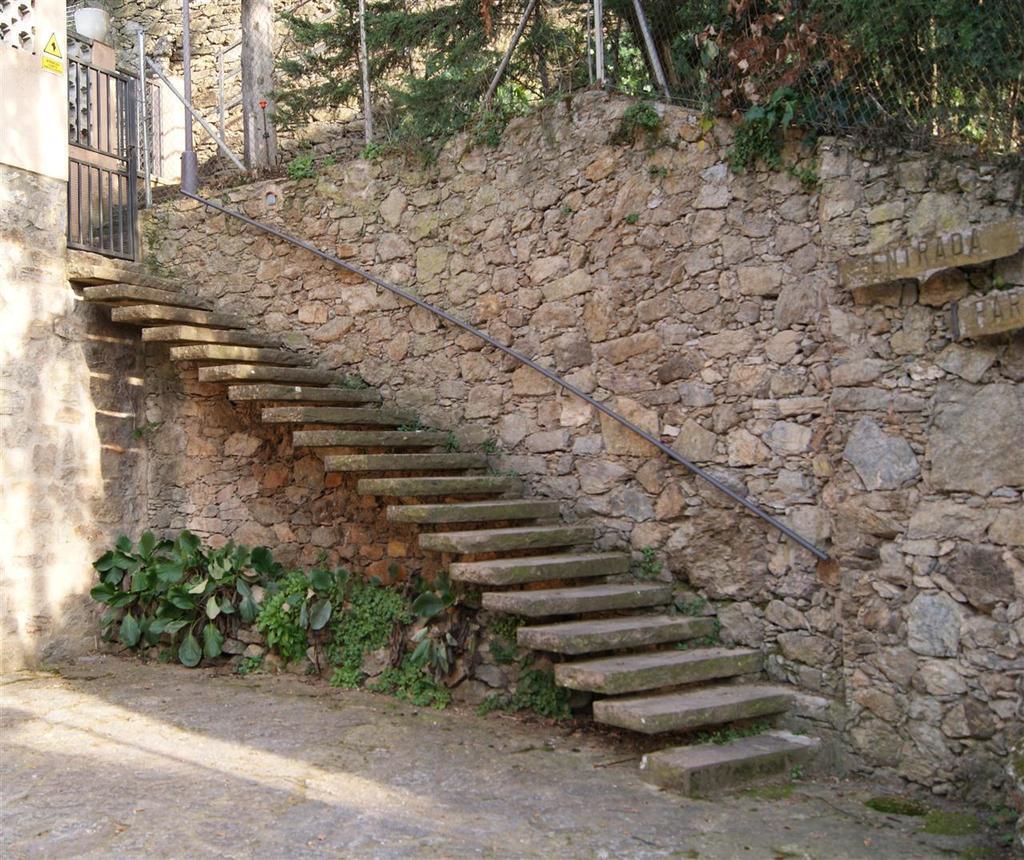In one or two sentences, can you explain what this image depicts? In this image I can see the stairs to the wall. Under the stairs there are some plants on the ground. On the top of the image there are some trees and there is a gate. 